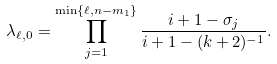<formula> <loc_0><loc_0><loc_500><loc_500>\lambda _ { \ell , 0 } = \prod _ { j = 1 } ^ { \min \{ \ell , n - m _ { 1 } \} } \frac { i + 1 - \sigma _ { j } } { i + 1 - ( k + 2 ) ^ { - 1 } } .</formula> 